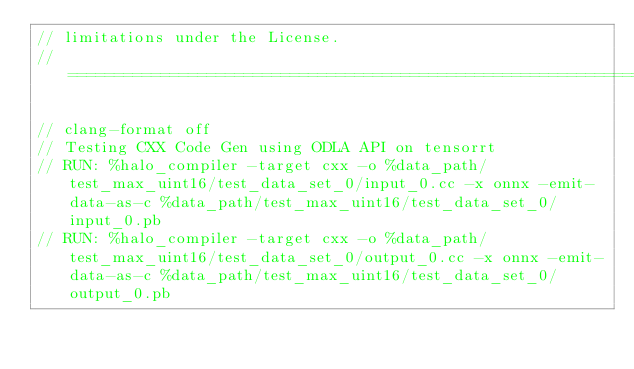<code> <loc_0><loc_0><loc_500><loc_500><_C++_>// limitations under the License.
// =============================================================================

// clang-format off
// Testing CXX Code Gen using ODLA API on tensorrt
// RUN: %halo_compiler -target cxx -o %data_path/test_max_uint16/test_data_set_0/input_0.cc -x onnx -emit-data-as-c %data_path/test_max_uint16/test_data_set_0/input_0.pb
// RUN: %halo_compiler -target cxx -o %data_path/test_max_uint16/test_data_set_0/output_0.cc -x onnx -emit-data-as-c %data_path/test_max_uint16/test_data_set_0/output_0.pb</code> 